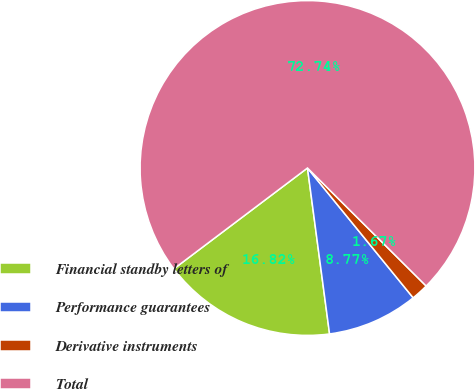<chart> <loc_0><loc_0><loc_500><loc_500><pie_chart><fcel>Financial standby letters of<fcel>Performance guarantees<fcel>Derivative instruments<fcel>Total<nl><fcel>16.82%<fcel>8.77%<fcel>1.67%<fcel>72.75%<nl></chart> 